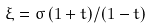<formula> <loc_0><loc_0><loc_500><loc_500>\xi = \sigma \, ( 1 + t ) / ( 1 - t )</formula> 